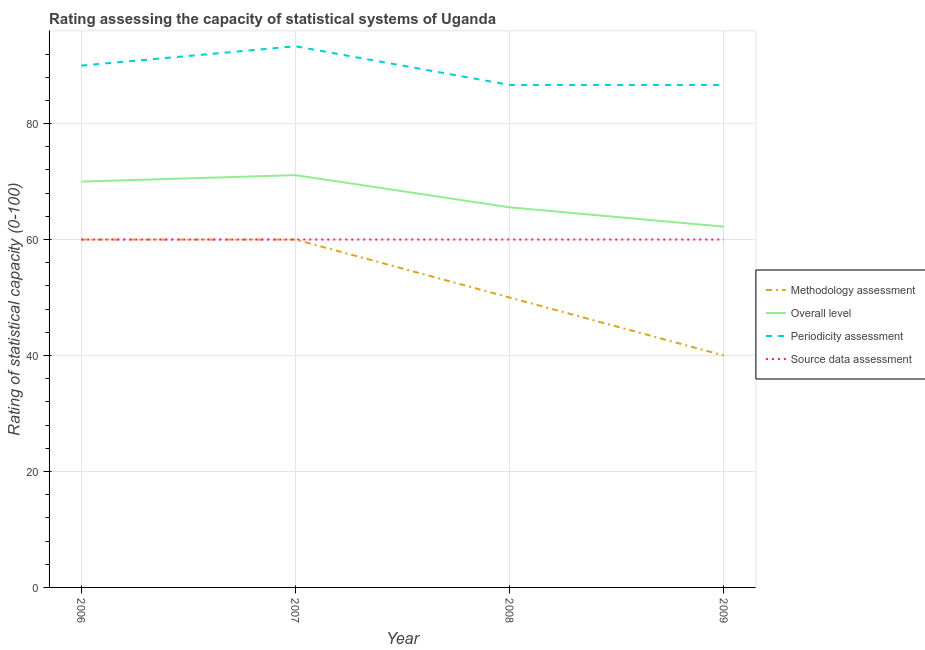How many different coloured lines are there?
Make the answer very short. 4. Does the line corresponding to periodicity assessment rating intersect with the line corresponding to methodology assessment rating?
Provide a succinct answer. No. Is the number of lines equal to the number of legend labels?
Make the answer very short. Yes. What is the periodicity assessment rating in 2007?
Offer a terse response. 93.33. Across all years, what is the maximum source data assessment rating?
Offer a terse response. 60. Across all years, what is the minimum overall level rating?
Your response must be concise. 62.22. What is the total source data assessment rating in the graph?
Ensure brevity in your answer.  240. What is the difference between the overall level rating in 2006 and that in 2009?
Provide a succinct answer. 7.78. What is the difference between the methodology assessment rating in 2009 and the periodicity assessment rating in 2007?
Your response must be concise. -53.33. What is the average methodology assessment rating per year?
Offer a very short reply. 52.5. In the year 2008, what is the difference between the overall level rating and methodology assessment rating?
Give a very brief answer. 15.56. What is the ratio of the methodology assessment rating in 2008 to that in 2009?
Your response must be concise. 1.25. Is the source data assessment rating in 2008 less than that in 2009?
Offer a terse response. No. Is the difference between the overall level rating in 2008 and 2009 greater than the difference between the periodicity assessment rating in 2008 and 2009?
Offer a terse response. Yes. What is the difference between the highest and the second highest overall level rating?
Make the answer very short. 1.11. What is the difference between the highest and the lowest methodology assessment rating?
Your response must be concise. 20. Is it the case that in every year, the sum of the methodology assessment rating and overall level rating is greater than the periodicity assessment rating?
Provide a succinct answer. Yes. Does the methodology assessment rating monotonically increase over the years?
Your response must be concise. No. How many lines are there?
Offer a terse response. 4. What is the difference between two consecutive major ticks on the Y-axis?
Offer a very short reply. 20. Are the values on the major ticks of Y-axis written in scientific E-notation?
Ensure brevity in your answer.  No. Does the graph contain grids?
Provide a succinct answer. Yes. How many legend labels are there?
Keep it short and to the point. 4. How are the legend labels stacked?
Make the answer very short. Vertical. What is the title of the graph?
Provide a succinct answer. Rating assessing the capacity of statistical systems of Uganda. What is the label or title of the Y-axis?
Offer a very short reply. Rating of statistical capacity (0-100). What is the Rating of statistical capacity (0-100) in Methodology assessment in 2006?
Keep it short and to the point. 60. What is the Rating of statistical capacity (0-100) in Source data assessment in 2006?
Provide a succinct answer. 60. What is the Rating of statistical capacity (0-100) in Methodology assessment in 2007?
Offer a terse response. 60. What is the Rating of statistical capacity (0-100) in Overall level in 2007?
Give a very brief answer. 71.11. What is the Rating of statistical capacity (0-100) in Periodicity assessment in 2007?
Your answer should be very brief. 93.33. What is the Rating of statistical capacity (0-100) in Source data assessment in 2007?
Offer a terse response. 60. What is the Rating of statistical capacity (0-100) in Methodology assessment in 2008?
Your answer should be very brief. 50. What is the Rating of statistical capacity (0-100) of Overall level in 2008?
Make the answer very short. 65.56. What is the Rating of statistical capacity (0-100) of Periodicity assessment in 2008?
Your answer should be compact. 86.67. What is the Rating of statistical capacity (0-100) of Source data assessment in 2008?
Give a very brief answer. 60. What is the Rating of statistical capacity (0-100) in Overall level in 2009?
Ensure brevity in your answer.  62.22. What is the Rating of statistical capacity (0-100) of Periodicity assessment in 2009?
Provide a short and direct response. 86.67. What is the Rating of statistical capacity (0-100) of Source data assessment in 2009?
Offer a terse response. 60. Across all years, what is the maximum Rating of statistical capacity (0-100) in Methodology assessment?
Keep it short and to the point. 60. Across all years, what is the maximum Rating of statistical capacity (0-100) in Overall level?
Offer a very short reply. 71.11. Across all years, what is the maximum Rating of statistical capacity (0-100) of Periodicity assessment?
Make the answer very short. 93.33. Across all years, what is the minimum Rating of statistical capacity (0-100) in Overall level?
Give a very brief answer. 62.22. Across all years, what is the minimum Rating of statistical capacity (0-100) of Periodicity assessment?
Ensure brevity in your answer.  86.67. Across all years, what is the minimum Rating of statistical capacity (0-100) of Source data assessment?
Offer a very short reply. 60. What is the total Rating of statistical capacity (0-100) in Methodology assessment in the graph?
Keep it short and to the point. 210. What is the total Rating of statistical capacity (0-100) of Overall level in the graph?
Give a very brief answer. 268.89. What is the total Rating of statistical capacity (0-100) in Periodicity assessment in the graph?
Your response must be concise. 356.67. What is the total Rating of statistical capacity (0-100) of Source data assessment in the graph?
Your answer should be compact. 240. What is the difference between the Rating of statistical capacity (0-100) in Overall level in 2006 and that in 2007?
Your response must be concise. -1.11. What is the difference between the Rating of statistical capacity (0-100) in Periodicity assessment in 2006 and that in 2007?
Provide a succinct answer. -3.33. What is the difference between the Rating of statistical capacity (0-100) of Methodology assessment in 2006 and that in 2008?
Provide a succinct answer. 10. What is the difference between the Rating of statistical capacity (0-100) of Overall level in 2006 and that in 2008?
Give a very brief answer. 4.44. What is the difference between the Rating of statistical capacity (0-100) in Source data assessment in 2006 and that in 2008?
Ensure brevity in your answer.  0. What is the difference between the Rating of statistical capacity (0-100) of Overall level in 2006 and that in 2009?
Give a very brief answer. 7.78. What is the difference between the Rating of statistical capacity (0-100) in Source data assessment in 2006 and that in 2009?
Your response must be concise. 0. What is the difference between the Rating of statistical capacity (0-100) of Methodology assessment in 2007 and that in 2008?
Offer a very short reply. 10. What is the difference between the Rating of statistical capacity (0-100) of Overall level in 2007 and that in 2008?
Offer a very short reply. 5.56. What is the difference between the Rating of statistical capacity (0-100) of Periodicity assessment in 2007 and that in 2008?
Offer a very short reply. 6.67. What is the difference between the Rating of statistical capacity (0-100) in Overall level in 2007 and that in 2009?
Offer a terse response. 8.89. What is the difference between the Rating of statistical capacity (0-100) in Periodicity assessment in 2007 and that in 2009?
Provide a short and direct response. 6.67. What is the difference between the Rating of statistical capacity (0-100) of Source data assessment in 2007 and that in 2009?
Keep it short and to the point. 0. What is the difference between the Rating of statistical capacity (0-100) in Methodology assessment in 2006 and the Rating of statistical capacity (0-100) in Overall level in 2007?
Offer a very short reply. -11.11. What is the difference between the Rating of statistical capacity (0-100) in Methodology assessment in 2006 and the Rating of statistical capacity (0-100) in Periodicity assessment in 2007?
Offer a terse response. -33.33. What is the difference between the Rating of statistical capacity (0-100) of Methodology assessment in 2006 and the Rating of statistical capacity (0-100) of Source data assessment in 2007?
Provide a short and direct response. 0. What is the difference between the Rating of statistical capacity (0-100) of Overall level in 2006 and the Rating of statistical capacity (0-100) of Periodicity assessment in 2007?
Ensure brevity in your answer.  -23.33. What is the difference between the Rating of statistical capacity (0-100) of Periodicity assessment in 2006 and the Rating of statistical capacity (0-100) of Source data assessment in 2007?
Offer a terse response. 30. What is the difference between the Rating of statistical capacity (0-100) in Methodology assessment in 2006 and the Rating of statistical capacity (0-100) in Overall level in 2008?
Offer a very short reply. -5.56. What is the difference between the Rating of statistical capacity (0-100) of Methodology assessment in 2006 and the Rating of statistical capacity (0-100) of Periodicity assessment in 2008?
Ensure brevity in your answer.  -26.67. What is the difference between the Rating of statistical capacity (0-100) in Overall level in 2006 and the Rating of statistical capacity (0-100) in Periodicity assessment in 2008?
Offer a terse response. -16.67. What is the difference between the Rating of statistical capacity (0-100) of Periodicity assessment in 2006 and the Rating of statistical capacity (0-100) of Source data assessment in 2008?
Give a very brief answer. 30. What is the difference between the Rating of statistical capacity (0-100) in Methodology assessment in 2006 and the Rating of statistical capacity (0-100) in Overall level in 2009?
Your answer should be very brief. -2.22. What is the difference between the Rating of statistical capacity (0-100) in Methodology assessment in 2006 and the Rating of statistical capacity (0-100) in Periodicity assessment in 2009?
Your answer should be compact. -26.67. What is the difference between the Rating of statistical capacity (0-100) in Methodology assessment in 2006 and the Rating of statistical capacity (0-100) in Source data assessment in 2009?
Your answer should be compact. 0. What is the difference between the Rating of statistical capacity (0-100) in Overall level in 2006 and the Rating of statistical capacity (0-100) in Periodicity assessment in 2009?
Your answer should be compact. -16.67. What is the difference between the Rating of statistical capacity (0-100) in Periodicity assessment in 2006 and the Rating of statistical capacity (0-100) in Source data assessment in 2009?
Provide a short and direct response. 30. What is the difference between the Rating of statistical capacity (0-100) in Methodology assessment in 2007 and the Rating of statistical capacity (0-100) in Overall level in 2008?
Keep it short and to the point. -5.56. What is the difference between the Rating of statistical capacity (0-100) of Methodology assessment in 2007 and the Rating of statistical capacity (0-100) of Periodicity assessment in 2008?
Give a very brief answer. -26.67. What is the difference between the Rating of statistical capacity (0-100) of Methodology assessment in 2007 and the Rating of statistical capacity (0-100) of Source data assessment in 2008?
Ensure brevity in your answer.  0. What is the difference between the Rating of statistical capacity (0-100) in Overall level in 2007 and the Rating of statistical capacity (0-100) in Periodicity assessment in 2008?
Your response must be concise. -15.56. What is the difference between the Rating of statistical capacity (0-100) of Overall level in 2007 and the Rating of statistical capacity (0-100) of Source data assessment in 2008?
Keep it short and to the point. 11.11. What is the difference between the Rating of statistical capacity (0-100) of Periodicity assessment in 2007 and the Rating of statistical capacity (0-100) of Source data assessment in 2008?
Your answer should be very brief. 33.33. What is the difference between the Rating of statistical capacity (0-100) in Methodology assessment in 2007 and the Rating of statistical capacity (0-100) in Overall level in 2009?
Keep it short and to the point. -2.22. What is the difference between the Rating of statistical capacity (0-100) of Methodology assessment in 2007 and the Rating of statistical capacity (0-100) of Periodicity assessment in 2009?
Your answer should be very brief. -26.67. What is the difference between the Rating of statistical capacity (0-100) in Overall level in 2007 and the Rating of statistical capacity (0-100) in Periodicity assessment in 2009?
Offer a terse response. -15.56. What is the difference between the Rating of statistical capacity (0-100) of Overall level in 2007 and the Rating of statistical capacity (0-100) of Source data assessment in 2009?
Keep it short and to the point. 11.11. What is the difference between the Rating of statistical capacity (0-100) of Periodicity assessment in 2007 and the Rating of statistical capacity (0-100) of Source data assessment in 2009?
Your answer should be compact. 33.33. What is the difference between the Rating of statistical capacity (0-100) in Methodology assessment in 2008 and the Rating of statistical capacity (0-100) in Overall level in 2009?
Ensure brevity in your answer.  -12.22. What is the difference between the Rating of statistical capacity (0-100) in Methodology assessment in 2008 and the Rating of statistical capacity (0-100) in Periodicity assessment in 2009?
Your response must be concise. -36.67. What is the difference between the Rating of statistical capacity (0-100) of Overall level in 2008 and the Rating of statistical capacity (0-100) of Periodicity assessment in 2009?
Offer a very short reply. -21.11. What is the difference between the Rating of statistical capacity (0-100) in Overall level in 2008 and the Rating of statistical capacity (0-100) in Source data assessment in 2009?
Offer a very short reply. 5.56. What is the difference between the Rating of statistical capacity (0-100) of Periodicity assessment in 2008 and the Rating of statistical capacity (0-100) of Source data assessment in 2009?
Make the answer very short. 26.67. What is the average Rating of statistical capacity (0-100) of Methodology assessment per year?
Make the answer very short. 52.5. What is the average Rating of statistical capacity (0-100) of Overall level per year?
Provide a short and direct response. 67.22. What is the average Rating of statistical capacity (0-100) in Periodicity assessment per year?
Offer a terse response. 89.17. In the year 2007, what is the difference between the Rating of statistical capacity (0-100) of Methodology assessment and Rating of statistical capacity (0-100) of Overall level?
Ensure brevity in your answer.  -11.11. In the year 2007, what is the difference between the Rating of statistical capacity (0-100) in Methodology assessment and Rating of statistical capacity (0-100) in Periodicity assessment?
Offer a very short reply. -33.33. In the year 2007, what is the difference between the Rating of statistical capacity (0-100) of Methodology assessment and Rating of statistical capacity (0-100) of Source data assessment?
Your response must be concise. 0. In the year 2007, what is the difference between the Rating of statistical capacity (0-100) in Overall level and Rating of statistical capacity (0-100) in Periodicity assessment?
Provide a short and direct response. -22.22. In the year 2007, what is the difference between the Rating of statistical capacity (0-100) of Overall level and Rating of statistical capacity (0-100) of Source data assessment?
Your response must be concise. 11.11. In the year 2007, what is the difference between the Rating of statistical capacity (0-100) in Periodicity assessment and Rating of statistical capacity (0-100) in Source data assessment?
Offer a very short reply. 33.33. In the year 2008, what is the difference between the Rating of statistical capacity (0-100) in Methodology assessment and Rating of statistical capacity (0-100) in Overall level?
Make the answer very short. -15.56. In the year 2008, what is the difference between the Rating of statistical capacity (0-100) in Methodology assessment and Rating of statistical capacity (0-100) in Periodicity assessment?
Your response must be concise. -36.67. In the year 2008, what is the difference between the Rating of statistical capacity (0-100) in Overall level and Rating of statistical capacity (0-100) in Periodicity assessment?
Your response must be concise. -21.11. In the year 2008, what is the difference between the Rating of statistical capacity (0-100) of Overall level and Rating of statistical capacity (0-100) of Source data assessment?
Offer a very short reply. 5.56. In the year 2008, what is the difference between the Rating of statistical capacity (0-100) of Periodicity assessment and Rating of statistical capacity (0-100) of Source data assessment?
Provide a short and direct response. 26.67. In the year 2009, what is the difference between the Rating of statistical capacity (0-100) in Methodology assessment and Rating of statistical capacity (0-100) in Overall level?
Your answer should be compact. -22.22. In the year 2009, what is the difference between the Rating of statistical capacity (0-100) in Methodology assessment and Rating of statistical capacity (0-100) in Periodicity assessment?
Your response must be concise. -46.67. In the year 2009, what is the difference between the Rating of statistical capacity (0-100) in Methodology assessment and Rating of statistical capacity (0-100) in Source data assessment?
Make the answer very short. -20. In the year 2009, what is the difference between the Rating of statistical capacity (0-100) in Overall level and Rating of statistical capacity (0-100) in Periodicity assessment?
Your answer should be compact. -24.44. In the year 2009, what is the difference between the Rating of statistical capacity (0-100) in Overall level and Rating of statistical capacity (0-100) in Source data assessment?
Offer a very short reply. 2.22. In the year 2009, what is the difference between the Rating of statistical capacity (0-100) in Periodicity assessment and Rating of statistical capacity (0-100) in Source data assessment?
Ensure brevity in your answer.  26.67. What is the ratio of the Rating of statistical capacity (0-100) of Overall level in 2006 to that in 2007?
Your answer should be compact. 0.98. What is the ratio of the Rating of statistical capacity (0-100) of Methodology assessment in 2006 to that in 2008?
Your response must be concise. 1.2. What is the ratio of the Rating of statistical capacity (0-100) in Overall level in 2006 to that in 2008?
Your answer should be very brief. 1.07. What is the ratio of the Rating of statistical capacity (0-100) of Methodology assessment in 2006 to that in 2009?
Your answer should be compact. 1.5. What is the ratio of the Rating of statistical capacity (0-100) in Overall level in 2006 to that in 2009?
Your answer should be very brief. 1.12. What is the ratio of the Rating of statistical capacity (0-100) of Source data assessment in 2006 to that in 2009?
Keep it short and to the point. 1. What is the ratio of the Rating of statistical capacity (0-100) in Overall level in 2007 to that in 2008?
Ensure brevity in your answer.  1.08. What is the ratio of the Rating of statistical capacity (0-100) in Periodicity assessment in 2007 to that in 2008?
Your answer should be compact. 1.08. What is the ratio of the Rating of statistical capacity (0-100) in Source data assessment in 2007 to that in 2008?
Give a very brief answer. 1. What is the ratio of the Rating of statistical capacity (0-100) in Methodology assessment in 2007 to that in 2009?
Offer a very short reply. 1.5. What is the ratio of the Rating of statistical capacity (0-100) in Overall level in 2007 to that in 2009?
Offer a very short reply. 1.14. What is the ratio of the Rating of statistical capacity (0-100) in Periodicity assessment in 2007 to that in 2009?
Offer a very short reply. 1.08. What is the ratio of the Rating of statistical capacity (0-100) in Source data assessment in 2007 to that in 2009?
Ensure brevity in your answer.  1. What is the ratio of the Rating of statistical capacity (0-100) in Methodology assessment in 2008 to that in 2009?
Ensure brevity in your answer.  1.25. What is the ratio of the Rating of statistical capacity (0-100) in Overall level in 2008 to that in 2009?
Your answer should be very brief. 1.05. What is the ratio of the Rating of statistical capacity (0-100) of Periodicity assessment in 2008 to that in 2009?
Provide a short and direct response. 1. What is the ratio of the Rating of statistical capacity (0-100) of Source data assessment in 2008 to that in 2009?
Make the answer very short. 1. What is the difference between the highest and the second highest Rating of statistical capacity (0-100) in Overall level?
Give a very brief answer. 1.11. What is the difference between the highest and the second highest Rating of statistical capacity (0-100) in Periodicity assessment?
Your answer should be compact. 3.33. What is the difference between the highest and the lowest Rating of statistical capacity (0-100) of Overall level?
Your answer should be very brief. 8.89. 